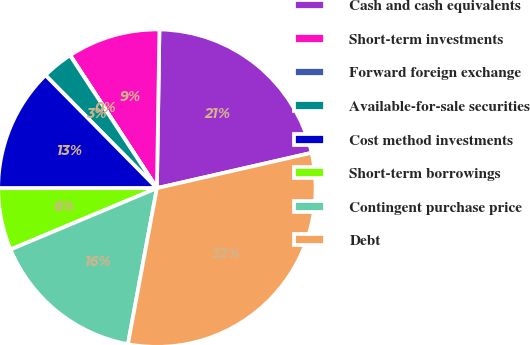Convert chart. <chart><loc_0><loc_0><loc_500><loc_500><pie_chart><fcel>Cash and cash equivalents<fcel>Short-term investments<fcel>Forward foreign exchange<fcel>Available-for-sale securities<fcel>Cost method investments<fcel>Short-term borrowings<fcel>Contingent purchase price<fcel>Debt<nl><fcel>21.17%<fcel>9.46%<fcel>0.02%<fcel>3.17%<fcel>12.61%<fcel>6.31%<fcel>15.76%<fcel>31.5%<nl></chart> 